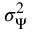<formula> <loc_0><loc_0><loc_500><loc_500>\sigma _ { \Psi } ^ { 2 }</formula> 